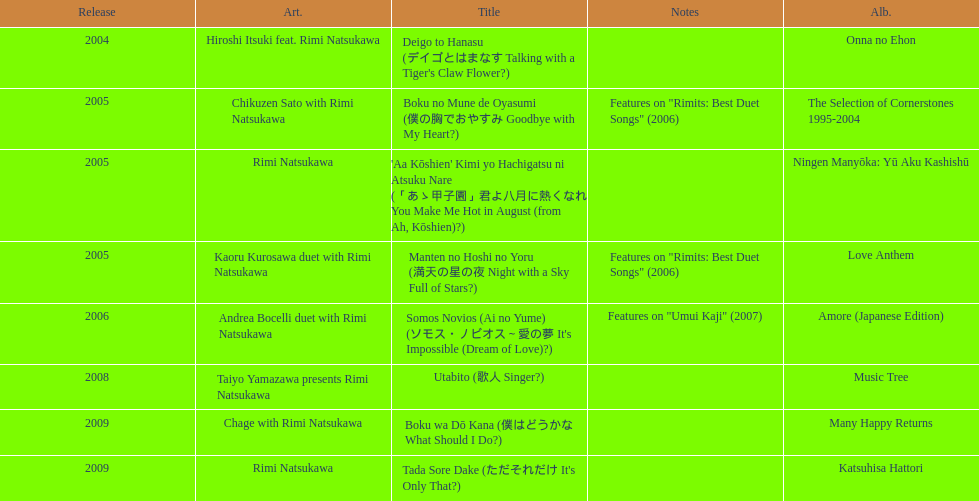Can you give me this table as a dict? {'header': ['Release', 'Art.', 'Title', 'Notes', 'Alb.'], 'rows': [['2004', 'Hiroshi Itsuki feat. Rimi Natsukawa', "Deigo to Hanasu (デイゴとはまなす Talking with a Tiger's Claw Flower?)", '', 'Onna no Ehon'], ['2005', 'Chikuzen Sato with Rimi Natsukawa', 'Boku no Mune de Oyasumi (僕の胸でおやすみ Goodbye with My Heart?)', 'Features on "Rimits: Best Duet Songs" (2006)', 'The Selection of Cornerstones 1995-2004'], ['2005', 'Rimi Natsukawa', "'Aa Kōshien' Kimi yo Hachigatsu ni Atsuku Nare (「あゝ甲子園」君よ八月に熱くなれ You Make Me Hot in August (from Ah, Kōshien)?)", '', 'Ningen Manyōka: Yū Aku Kashishū'], ['2005', 'Kaoru Kurosawa duet with Rimi Natsukawa', 'Manten no Hoshi no Yoru (満天の星の夜 Night with a Sky Full of Stars?)', 'Features on "Rimits: Best Duet Songs" (2006)', 'Love Anthem'], ['2006', 'Andrea Bocelli duet with Rimi Natsukawa', "Somos Novios (Ai no Yume) (ソモス・ノビオス～愛の夢 It's Impossible (Dream of Love)?)", 'Features on "Umui Kaji" (2007)', 'Amore (Japanese Edition)'], ['2008', 'Taiyo Yamazawa presents Rimi Natsukawa', 'Utabito (歌人 Singer?)', '', 'Music Tree'], ['2009', 'Chage with Rimi Natsukawa', 'Boku wa Dō Kana (僕はどうかな What Should I Do?)', '', 'Many Happy Returns'], ['2009', 'Rimi Natsukawa', "Tada Sore Dake (ただそれだけ It's Only That?)", '', 'Katsuhisa Hattori']]} How many other appearance did this artist make in 2005? 3. 